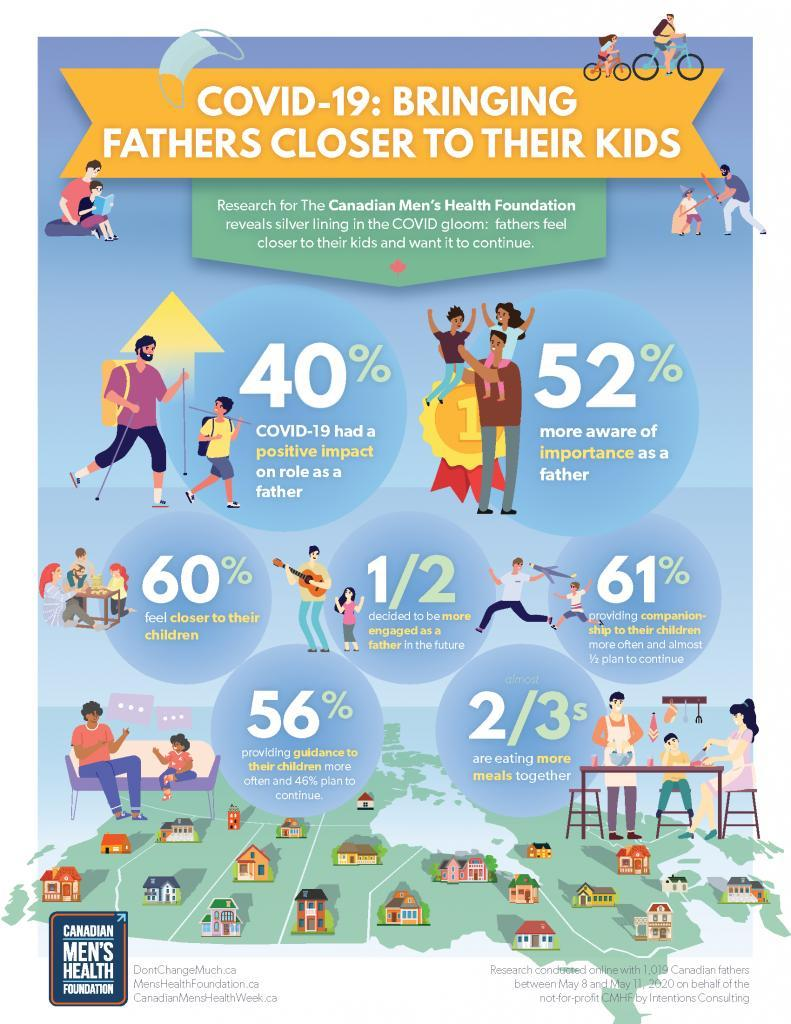What percent of the Canadian men are more aware of the importance as a father according to the research conducted by CMHF?
Answer the question with a short phrase. 52% What portion of the Canadian men population decided to be more engaged as a father in the future according to the research conducted by CMHF? 1/2 What percent of Canadian fathers were providing companionship to their children more often during the COVID-19 period according to the research conducted by CMHF? 61% What percent of Canadian fathers felt closer to their children during the COVID-19 period according to the research conducted by CMHF? 60% What percent of Canadian fathers were providing guidance to their children more often during the COVID-19 period according to the research conducted by CMHF? 56% 